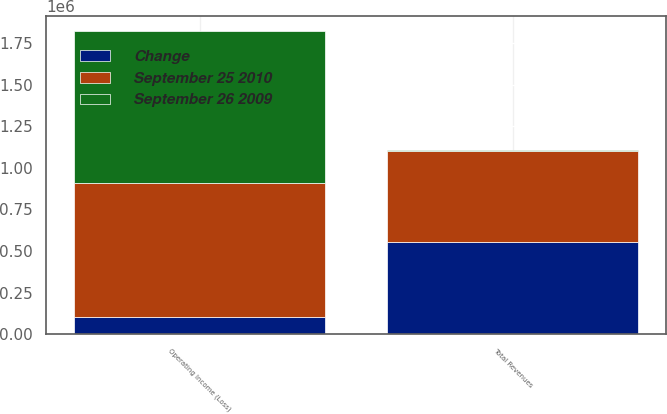Convert chart to OTSL. <chart><loc_0><loc_0><loc_500><loc_500><stacked_bar_chart><ecel><fcel>Total Revenues<fcel>Operating Income (Loss)<nl><fcel>Change<fcel>552501<fcel>100469<nl><fcel>September 25 2010<fcel>547892<fcel>809640<nl><fcel>September 26 2009<fcel>4609<fcel>910109<nl></chart> 